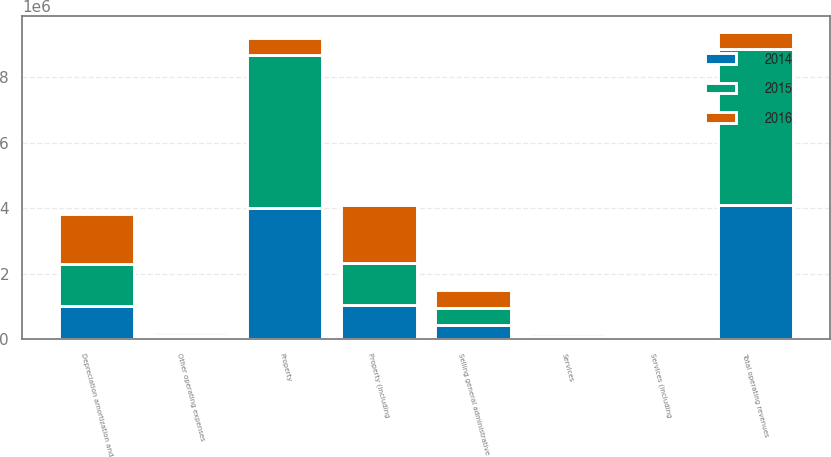<chart> <loc_0><loc_0><loc_500><loc_500><stacked_bar_chart><ecel><fcel>Property<fcel>Services<fcel>Total operating revenues<fcel>Property (including<fcel>Services (including<fcel>Depreciation amortization and<fcel>Selling general administrative<fcel>Other operating expenses<nl><fcel>2016<fcel>520615<fcel>72542<fcel>520615<fcel>1.76269e+06<fcel>27695<fcel>1.52564e+06<fcel>543395<fcel>73220<nl><fcel>2015<fcel>4.68039e+06<fcel>91128<fcel>4.77152e+06<fcel>1.27544e+06<fcel>33432<fcel>1.28533e+06<fcel>497835<fcel>66696<nl><fcel>2014<fcel>4.00685e+06<fcel>93194<fcel>4.10005e+06<fcel>1.05618e+06<fcel>38088<fcel>1.0038e+06<fcel>446542<fcel>68517<nl></chart> 